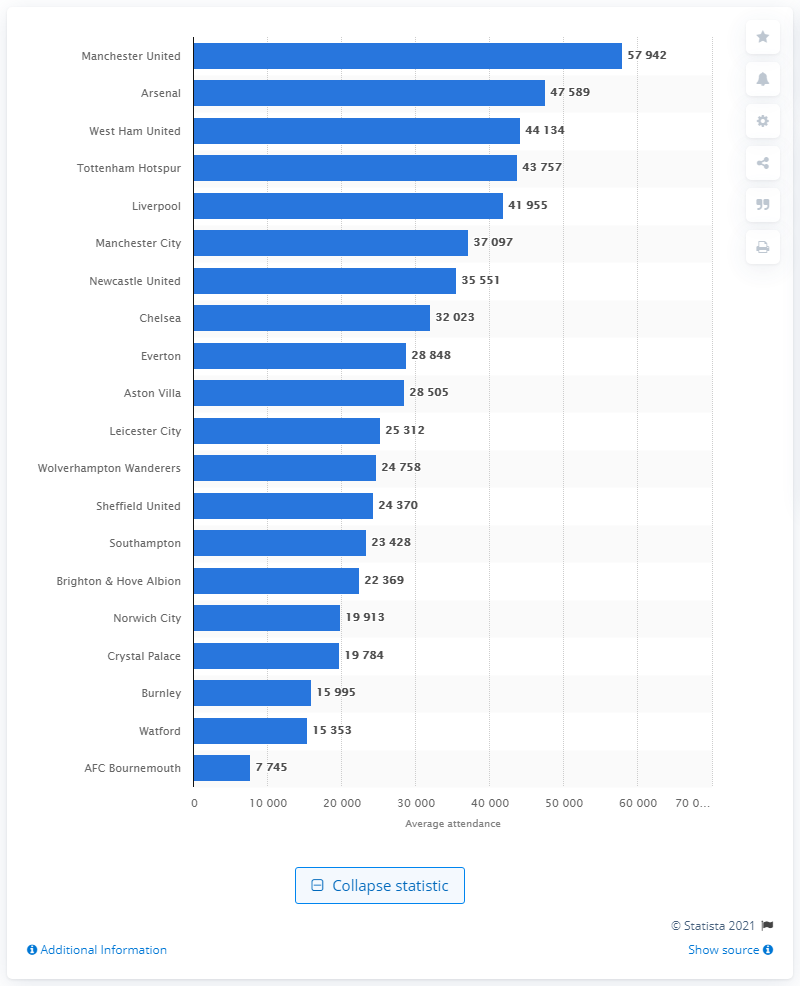Point out several critical features in this image. In the 2019/2020 season, Manchester United held the record for the highest attendance, outshining other teams in the league. 